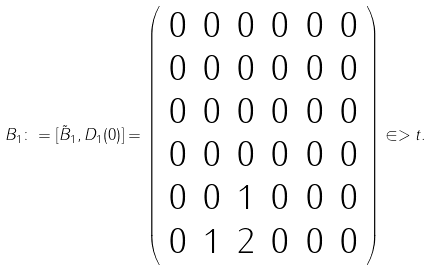<formula> <loc_0><loc_0><loc_500><loc_500>B _ { 1 } \colon = [ \tilde { B } _ { 1 } , D _ { 1 } ( 0 ) ] = \left ( \begin{array} { c c c c c c } 0 & 0 & 0 & 0 & 0 & 0 \\ 0 & 0 & 0 & 0 & 0 & 0 \\ 0 & 0 & 0 & 0 & 0 & 0 \\ 0 & 0 & 0 & 0 & 0 & 0 \\ 0 & 0 & 1 & 0 & 0 & 0 \\ 0 & 1 & 2 & 0 & 0 & 0 \end{array} \right ) \in > t .</formula> 